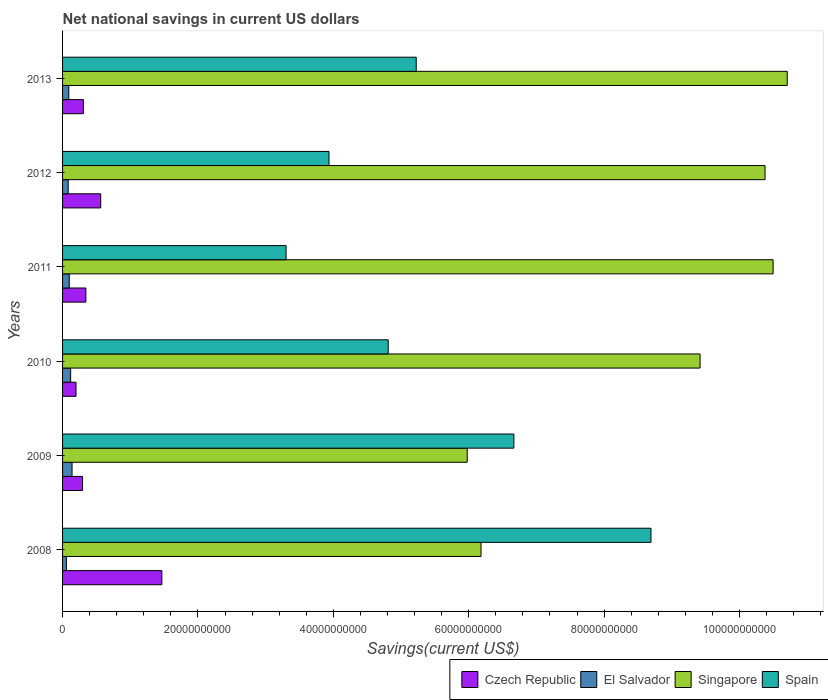How many different coloured bars are there?
Keep it short and to the point. 4. Are the number of bars on each tick of the Y-axis equal?
Keep it short and to the point. Yes. How many bars are there on the 6th tick from the top?
Provide a succinct answer. 4. In how many cases, is the number of bars for a given year not equal to the number of legend labels?
Make the answer very short. 0. What is the net national savings in Spain in 2010?
Your response must be concise. 4.81e+1. Across all years, what is the maximum net national savings in Czech Republic?
Offer a terse response. 1.47e+1. Across all years, what is the minimum net national savings in Spain?
Offer a very short reply. 3.30e+1. What is the total net national savings in Czech Republic in the graph?
Your answer should be compact. 3.18e+1. What is the difference between the net national savings in Czech Republic in 2010 and that in 2013?
Make the answer very short. -1.09e+09. What is the difference between the net national savings in Singapore in 2010 and the net national savings in El Salvador in 2008?
Make the answer very short. 9.36e+1. What is the average net national savings in Czech Republic per year?
Provide a succinct answer. 5.29e+09. In the year 2010, what is the difference between the net national savings in Spain and net national savings in El Salvador?
Your response must be concise. 4.69e+1. In how many years, is the net national savings in Singapore greater than 24000000000 US$?
Ensure brevity in your answer.  6. What is the ratio of the net national savings in Spain in 2012 to that in 2013?
Give a very brief answer. 0.75. Is the net national savings in El Salvador in 2010 less than that in 2013?
Give a very brief answer. No. What is the difference between the highest and the second highest net national savings in Czech Republic?
Your response must be concise. 9.03e+09. What is the difference between the highest and the lowest net national savings in Spain?
Provide a succinct answer. 5.39e+1. In how many years, is the net national savings in El Salvador greater than the average net national savings in El Salvador taken over all years?
Offer a terse response. 3. Is it the case that in every year, the sum of the net national savings in El Salvador and net national savings in Singapore is greater than the sum of net national savings in Spain and net national savings in Czech Republic?
Your answer should be compact. Yes. What does the 2nd bar from the top in 2010 represents?
Provide a succinct answer. Singapore. What does the 3rd bar from the bottom in 2013 represents?
Provide a succinct answer. Singapore. Is it the case that in every year, the sum of the net national savings in Spain and net national savings in El Salvador is greater than the net national savings in Singapore?
Keep it short and to the point. No. How many years are there in the graph?
Provide a short and direct response. 6. Does the graph contain any zero values?
Provide a succinct answer. No. Does the graph contain grids?
Make the answer very short. No. Where does the legend appear in the graph?
Your answer should be compact. Bottom right. How many legend labels are there?
Give a very brief answer. 4. What is the title of the graph?
Provide a succinct answer. Net national savings in current US dollars. Does "Egypt, Arab Rep." appear as one of the legend labels in the graph?
Give a very brief answer. No. What is the label or title of the X-axis?
Make the answer very short. Savings(current US$). What is the Savings(current US$) of Czech Republic in 2008?
Your response must be concise. 1.47e+1. What is the Savings(current US$) in El Salvador in 2008?
Offer a very short reply. 5.68e+08. What is the Savings(current US$) of Singapore in 2008?
Provide a short and direct response. 6.18e+1. What is the Savings(current US$) of Spain in 2008?
Your answer should be very brief. 8.69e+1. What is the Savings(current US$) of Czech Republic in 2009?
Your answer should be very brief. 2.95e+09. What is the Savings(current US$) in El Salvador in 2009?
Your answer should be compact. 1.40e+09. What is the Savings(current US$) of Singapore in 2009?
Give a very brief answer. 5.98e+1. What is the Savings(current US$) of Spain in 2009?
Keep it short and to the point. 6.67e+1. What is the Savings(current US$) of Czech Republic in 2010?
Ensure brevity in your answer.  1.99e+09. What is the Savings(current US$) in El Salvador in 2010?
Make the answer very short. 1.19e+09. What is the Savings(current US$) of Singapore in 2010?
Offer a terse response. 9.42e+1. What is the Savings(current US$) in Spain in 2010?
Give a very brief answer. 4.81e+1. What is the Savings(current US$) in Czech Republic in 2011?
Keep it short and to the point. 3.44e+09. What is the Savings(current US$) of El Salvador in 2011?
Your response must be concise. 9.87e+08. What is the Savings(current US$) of Singapore in 2011?
Your answer should be compact. 1.05e+11. What is the Savings(current US$) of Spain in 2011?
Keep it short and to the point. 3.30e+1. What is the Savings(current US$) of Czech Republic in 2012?
Offer a very short reply. 5.64e+09. What is the Savings(current US$) of El Salvador in 2012?
Make the answer very short. 8.30e+08. What is the Savings(current US$) in Singapore in 2012?
Your answer should be very brief. 1.04e+11. What is the Savings(current US$) in Spain in 2012?
Offer a very short reply. 3.94e+1. What is the Savings(current US$) in Czech Republic in 2013?
Keep it short and to the point. 3.07e+09. What is the Savings(current US$) of El Salvador in 2013?
Keep it short and to the point. 9.19e+08. What is the Savings(current US$) of Singapore in 2013?
Keep it short and to the point. 1.07e+11. What is the Savings(current US$) in Spain in 2013?
Ensure brevity in your answer.  5.22e+1. Across all years, what is the maximum Savings(current US$) of Czech Republic?
Your answer should be very brief. 1.47e+1. Across all years, what is the maximum Savings(current US$) in El Salvador?
Give a very brief answer. 1.40e+09. Across all years, what is the maximum Savings(current US$) of Singapore?
Your answer should be very brief. 1.07e+11. Across all years, what is the maximum Savings(current US$) of Spain?
Provide a short and direct response. 8.69e+1. Across all years, what is the minimum Savings(current US$) of Czech Republic?
Keep it short and to the point. 1.99e+09. Across all years, what is the minimum Savings(current US$) of El Salvador?
Keep it short and to the point. 5.68e+08. Across all years, what is the minimum Savings(current US$) of Singapore?
Your answer should be very brief. 5.98e+1. Across all years, what is the minimum Savings(current US$) in Spain?
Provide a short and direct response. 3.30e+1. What is the total Savings(current US$) of Czech Republic in the graph?
Make the answer very short. 3.18e+1. What is the total Savings(current US$) in El Salvador in the graph?
Keep it short and to the point. 5.90e+09. What is the total Savings(current US$) of Singapore in the graph?
Your answer should be compact. 5.32e+11. What is the total Savings(current US$) in Spain in the graph?
Ensure brevity in your answer.  3.26e+11. What is the difference between the Savings(current US$) in Czech Republic in 2008 and that in 2009?
Make the answer very short. 1.17e+1. What is the difference between the Savings(current US$) in El Salvador in 2008 and that in 2009?
Ensure brevity in your answer.  -8.33e+08. What is the difference between the Savings(current US$) in Singapore in 2008 and that in 2009?
Keep it short and to the point. 2.04e+09. What is the difference between the Savings(current US$) of Spain in 2008 and that in 2009?
Offer a very short reply. 2.03e+1. What is the difference between the Savings(current US$) in Czech Republic in 2008 and that in 2010?
Your response must be concise. 1.27e+1. What is the difference between the Savings(current US$) of El Salvador in 2008 and that in 2010?
Provide a succinct answer. -6.24e+08. What is the difference between the Savings(current US$) in Singapore in 2008 and that in 2010?
Provide a short and direct response. -3.24e+1. What is the difference between the Savings(current US$) in Spain in 2008 and that in 2010?
Your answer should be very brief. 3.88e+1. What is the difference between the Savings(current US$) in Czech Republic in 2008 and that in 2011?
Give a very brief answer. 1.12e+1. What is the difference between the Savings(current US$) of El Salvador in 2008 and that in 2011?
Give a very brief answer. -4.18e+08. What is the difference between the Savings(current US$) of Singapore in 2008 and that in 2011?
Your answer should be compact. -4.31e+1. What is the difference between the Savings(current US$) in Spain in 2008 and that in 2011?
Your answer should be very brief. 5.39e+1. What is the difference between the Savings(current US$) in Czech Republic in 2008 and that in 2012?
Offer a very short reply. 9.03e+09. What is the difference between the Savings(current US$) of El Salvador in 2008 and that in 2012?
Keep it short and to the point. -2.62e+08. What is the difference between the Savings(current US$) in Singapore in 2008 and that in 2012?
Provide a succinct answer. -4.20e+1. What is the difference between the Savings(current US$) of Spain in 2008 and that in 2012?
Provide a short and direct response. 4.76e+1. What is the difference between the Savings(current US$) in Czech Republic in 2008 and that in 2013?
Give a very brief answer. 1.16e+1. What is the difference between the Savings(current US$) of El Salvador in 2008 and that in 2013?
Your answer should be very brief. -3.51e+08. What is the difference between the Savings(current US$) of Singapore in 2008 and that in 2013?
Your answer should be compact. -4.52e+1. What is the difference between the Savings(current US$) in Spain in 2008 and that in 2013?
Provide a short and direct response. 3.47e+1. What is the difference between the Savings(current US$) of Czech Republic in 2009 and that in 2010?
Your answer should be compact. 9.65e+08. What is the difference between the Savings(current US$) in El Salvador in 2009 and that in 2010?
Give a very brief answer. 2.10e+08. What is the difference between the Savings(current US$) of Singapore in 2009 and that in 2010?
Provide a succinct answer. -3.44e+1. What is the difference between the Savings(current US$) of Spain in 2009 and that in 2010?
Make the answer very short. 1.86e+1. What is the difference between the Savings(current US$) in Czech Republic in 2009 and that in 2011?
Provide a short and direct response. -4.91e+08. What is the difference between the Savings(current US$) in El Salvador in 2009 and that in 2011?
Make the answer very short. 4.15e+08. What is the difference between the Savings(current US$) of Singapore in 2009 and that in 2011?
Offer a terse response. -4.52e+1. What is the difference between the Savings(current US$) of Spain in 2009 and that in 2011?
Offer a very short reply. 3.37e+1. What is the difference between the Savings(current US$) of Czech Republic in 2009 and that in 2012?
Ensure brevity in your answer.  -2.68e+09. What is the difference between the Savings(current US$) of El Salvador in 2009 and that in 2012?
Make the answer very short. 5.71e+08. What is the difference between the Savings(current US$) of Singapore in 2009 and that in 2012?
Keep it short and to the point. -4.40e+1. What is the difference between the Savings(current US$) of Spain in 2009 and that in 2012?
Your answer should be compact. 2.73e+1. What is the difference between the Savings(current US$) in Czech Republic in 2009 and that in 2013?
Keep it short and to the point. -1.21e+08. What is the difference between the Savings(current US$) in El Salvador in 2009 and that in 2013?
Offer a terse response. 4.82e+08. What is the difference between the Savings(current US$) of Singapore in 2009 and that in 2013?
Your answer should be compact. -4.73e+1. What is the difference between the Savings(current US$) of Spain in 2009 and that in 2013?
Give a very brief answer. 1.44e+1. What is the difference between the Savings(current US$) of Czech Republic in 2010 and that in 2011?
Your response must be concise. -1.46e+09. What is the difference between the Savings(current US$) of El Salvador in 2010 and that in 2011?
Offer a very short reply. 2.05e+08. What is the difference between the Savings(current US$) in Singapore in 2010 and that in 2011?
Provide a succinct answer. -1.08e+1. What is the difference between the Savings(current US$) in Spain in 2010 and that in 2011?
Provide a short and direct response. 1.51e+1. What is the difference between the Savings(current US$) in Czech Republic in 2010 and that in 2012?
Your response must be concise. -3.65e+09. What is the difference between the Savings(current US$) in El Salvador in 2010 and that in 2012?
Make the answer very short. 3.62e+08. What is the difference between the Savings(current US$) in Singapore in 2010 and that in 2012?
Your answer should be compact. -9.60e+09. What is the difference between the Savings(current US$) of Spain in 2010 and that in 2012?
Offer a terse response. 8.75e+09. What is the difference between the Savings(current US$) of Czech Republic in 2010 and that in 2013?
Your response must be concise. -1.09e+09. What is the difference between the Savings(current US$) in El Salvador in 2010 and that in 2013?
Your answer should be very brief. 2.73e+08. What is the difference between the Savings(current US$) in Singapore in 2010 and that in 2013?
Offer a terse response. -1.29e+1. What is the difference between the Savings(current US$) of Spain in 2010 and that in 2013?
Give a very brief answer. -4.14e+09. What is the difference between the Savings(current US$) of Czech Republic in 2011 and that in 2012?
Give a very brief answer. -2.19e+09. What is the difference between the Savings(current US$) in El Salvador in 2011 and that in 2012?
Make the answer very short. 1.56e+08. What is the difference between the Savings(current US$) in Singapore in 2011 and that in 2012?
Your response must be concise. 1.19e+09. What is the difference between the Savings(current US$) of Spain in 2011 and that in 2012?
Provide a short and direct response. -6.34e+09. What is the difference between the Savings(current US$) in Czech Republic in 2011 and that in 2013?
Keep it short and to the point. 3.71e+08. What is the difference between the Savings(current US$) of El Salvador in 2011 and that in 2013?
Make the answer very short. 6.75e+07. What is the difference between the Savings(current US$) in Singapore in 2011 and that in 2013?
Your answer should be compact. -2.09e+09. What is the difference between the Savings(current US$) of Spain in 2011 and that in 2013?
Ensure brevity in your answer.  -1.92e+1. What is the difference between the Savings(current US$) in Czech Republic in 2012 and that in 2013?
Your answer should be compact. 2.56e+09. What is the difference between the Savings(current US$) in El Salvador in 2012 and that in 2013?
Make the answer very short. -8.90e+07. What is the difference between the Savings(current US$) in Singapore in 2012 and that in 2013?
Make the answer very short. -3.28e+09. What is the difference between the Savings(current US$) of Spain in 2012 and that in 2013?
Provide a succinct answer. -1.29e+1. What is the difference between the Savings(current US$) in Czech Republic in 2008 and the Savings(current US$) in El Salvador in 2009?
Your answer should be compact. 1.33e+1. What is the difference between the Savings(current US$) of Czech Republic in 2008 and the Savings(current US$) of Singapore in 2009?
Offer a terse response. -4.51e+1. What is the difference between the Savings(current US$) in Czech Republic in 2008 and the Savings(current US$) in Spain in 2009?
Provide a succinct answer. -5.20e+1. What is the difference between the Savings(current US$) in El Salvador in 2008 and the Savings(current US$) in Singapore in 2009?
Your answer should be compact. -5.92e+1. What is the difference between the Savings(current US$) of El Salvador in 2008 and the Savings(current US$) of Spain in 2009?
Provide a succinct answer. -6.61e+1. What is the difference between the Savings(current US$) of Singapore in 2008 and the Savings(current US$) of Spain in 2009?
Your response must be concise. -4.85e+09. What is the difference between the Savings(current US$) of Czech Republic in 2008 and the Savings(current US$) of El Salvador in 2010?
Your response must be concise. 1.35e+1. What is the difference between the Savings(current US$) in Czech Republic in 2008 and the Savings(current US$) in Singapore in 2010?
Give a very brief answer. -7.95e+1. What is the difference between the Savings(current US$) of Czech Republic in 2008 and the Savings(current US$) of Spain in 2010?
Provide a short and direct response. -3.34e+1. What is the difference between the Savings(current US$) of El Salvador in 2008 and the Savings(current US$) of Singapore in 2010?
Offer a very short reply. -9.36e+1. What is the difference between the Savings(current US$) of El Salvador in 2008 and the Savings(current US$) of Spain in 2010?
Provide a succinct answer. -4.75e+1. What is the difference between the Savings(current US$) of Singapore in 2008 and the Savings(current US$) of Spain in 2010?
Ensure brevity in your answer.  1.37e+1. What is the difference between the Savings(current US$) in Czech Republic in 2008 and the Savings(current US$) in El Salvador in 2011?
Make the answer very short. 1.37e+1. What is the difference between the Savings(current US$) of Czech Republic in 2008 and the Savings(current US$) of Singapore in 2011?
Provide a succinct answer. -9.03e+1. What is the difference between the Savings(current US$) in Czech Republic in 2008 and the Savings(current US$) in Spain in 2011?
Provide a short and direct response. -1.84e+1. What is the difference between the Savings(current US$) of El Salvador in 2008 and the Savings(current US$) of Singapore in 2011?
Give a very brief answer. -1.04e+11. What is the difference between the Savings(current US$) in El Salvador in 2008 and the Savings(current US$) in Spain in 2011?
Keep it short and to the point. -3.24e+1. What is the difference between the Savings(current US$) of Singapore in 2008 and the Savings(current US$) of Spain in 2011?
Offer a very short reply. 2.88e+1. What is the difference between the Savings(current US$) of Czech Republic in 2008 and the Savings(current US$) of El Salvador in 2012?
Offer a very short reply. 1.38e+1. What is the difference between the Savings(current US$) of Czech Republic in 2008 and the Savings(current US$) of Singapore in 2012?
Provide a succinct answer. -8.91e+1. What is the difference between the Savings(current US$) of Czech Republic in 2008 and the Savings(current US$) of Spain in 2012?
Provide a short and direct response. -2.47e+1. What is the difference between the Savings(current US$) in El Salvador in 2008 and the Savings(current US$) in Singapore in 2012?
Provide a short and direct response. -1.03e+11. What is the difference between the Savings(current US$) in El Salvador in 2008 and the Savings(current US$) in Spain in 2012?
Offer a terse response. -3.88e+1. What is the difference between the Savings(current US$) in Singapore in 2008 and the Savings(current US$) in Spain in 2012?
Offer a terse response. 2.25e+1. What is the difference between the Savings(current US$) of Czech Republic in 2008 and the Savings(current US$) of El Salvador in 2013?
Ensure brevity in your answer.  1.37e+1. What is the difference between the Savings(current US$) of Czech Republic in 2008 and the Savings(current US$) of Singapore in 2013?
Your response must be concise. -9.24e+1. What is the difference between the Savings(current US$) of Czech Republic in 2008 and the Savings(current US$) of Spain in 2013?
Give a very brief answer. -3.76e+1. What is the difference between the Savings(current US$) in El Salvador in 2008 and the Savings(current US$) in Singapore in 2013?
Provide a succinct answer. -1.06e+11. What is the difference between the Savings(current US$) of El Salvador in 2008 and the Savings(current US$) of Spain in 2013?
Give a very brief answer. -5.17e+1. What is the difference between the Savings(current US$) of Singapore in 2008 and the Savings(current US$) of Spain in 2013?
Keep it short and to the point. 9.57e+09. What is the difference between the Savings(current US$) in Czech Republic in 2009 and the Savings(current US$) in El Salvador in 2010?
Your response must be concise. 1.76e+09. What is the difference between the Savings(current US$) in Czech Republic in 2009 and the Savings(current US$) in Singapore in 2010?
Your answer should be compact. -9.12e+1. What is the difference between the Savings(current US$) in Czech Republic in 2009 and the Savings(current US$) in Spain in 2010?
Give a very brief answer. -4.52e+1. What is the difference between the Savings(current US$) in El Salvador in 2009 and the Savings(current US$) in Singapore in 2010?
Make the answer very short. -9.28e+1. What is the difference between the Savings(current US$) of El Salvador in 2009 and the Savings(current US$) of Spain in 2010?
Offer a very short reply. -4.67e+1. What is the difference between the Savings(current US$) of Singapore in 2009 and the Savings(current US$) of Spain in 2010?
Your answer should be compact. 1.17e+1. What is the difference between the Savings(current US$) in Czech Republic in 2009 and the Savings(current US$) in El Salvador in 2011?
Provide a short and direct response. 1.97e+09. What is the difference between the Savings(current US$) in Czech Republic in 2009 and the Savings(current US$) in Singapore in 2011?
Offer a very short reply. -1.02e+11. What is the difference between the Savings(current US$) in Czech Republic in 2009 and the Savings(current US$) in Spain in 2011?
Provide a succinct answer. -3.01e+1. What is the difference between the Savings(current US$) in El Salvador in 2009 and the Savings(current US$) in Singapore in 2011?
Offer a terse response. -1.04e+11. What is the difference between the Savings(current US$) in El Salvador in 2009 and the Savings(current US$) in Spain in 2011?
Your answer should be compact. -3.16e+1. What is the difference between the Savings(current US$) of Singapore in 2009 and the Savings(current US$) of Spain in 2011?
Your answer should be very brief. 2.68e+1. What is the difference between the Savings(current US$) of Czech Republic in 2009 and the Savings(current US$) of El Salvador in 2012?
Offer a very short reply. 2.12e+09. What is the difference between the Savings(current US$) in Czech Republic in 2009 and the Savings(current US$) in Singapore in 2012?
Your answer should be compact. -1.01e+11. What is the difference between the Savings(current US$) in Czech Republic in 2009 and the Savings(current US$) in Spain in 2012?
Give a very brief answer. -3.64e+1. What is the difference between the Savings(current US$) of El Salvador in 2009 and the Savings(current US$) of Singapore in 2012?
Offer a very short reply. -1.02e+11. What is the difference between the Savings(current US$) of El Salvador in 2009 and the Savings(current US$) of Spain in 2012?
Keep it short and to the point. -3.80e+1. What is the difference between the Savings(current US$) of Singapore in 2009 and the Savings(current US$) of Spain in 2012?
Offer a terse response. 2.04e+1. What is the difference between the Savings(current US$) in Czech Republic in 2009 and the Savings(current US$) in El Salvador in 2013?
Provide a short and direct response. 2.03e+09. What is the difference between the Savings(current US$) of Czech Republic in 2009 and the Savings(current US$) of Singapore in 2013?
Provide a short and direct response. -1.04e+11. What is the difference between the Savings(current US$) of Czech Republic in 2009 and the Savings(current US$) of Spain in 2013?
Offer a terse response. -4.93e+1. What is the difference between the Savings(current US$) in El Salvador in 2009 and the Savings(current US$) in Singapore in 2013?
Ensure brevity in your answer.  -1.06e+11. What is the difference between the Savings(current US$) of El Salvador in 2009 and the Savings(current US$) of Spain in 2013?
Keep it short and to the point. -5.08e+1. What is the difference between the Savings(current US$) of Singapore in 2009 and the Savings(current US$) of Spain in 2013?
Give a very brief answer. 7.53e+09. What is the difference between the Savings(current US$) of Czech Republic in 2010 and the Savings(current US$) of El Salvador in 2011?
Offer a terse response. 1.00e+09. What is the difference between the Savings(current US$) in Czech Republic in 2010 and the Savings(current US$) in Singapore in 2011?
Provide a short and direct response. -1.03e+11. What is the difference between the Savings(current US$) in Czech Republic in 2010 and the Savings(current US$) in Spain in 2011?
Offer a very short reply. -3.10e+1. What is the difference between the Savings(current US$) in El Salvador in 2010 and the Savings(current US$) in Singapore in 2011?
Your answer should be very brief. -1.04e+11. What is the difference between the Savings(current US$) of El Salvador in 2010 and the Savings(current US$) of Spain in 2011?
Provide a short and direct response. -3.18e+1. What is the difference between the Savings(current US$) of Singapore in 2010 and the Savings(current US$) of Spain in 2011?
Provide a succinct answer. 6.12e+1. What is the difference between the Savings(current US$) in Czech Republic in 2010 and the Savings(current US$) in El Salvador in 2012?
Your response must be concise. 1.16e+09. What is the difference between the Savings(current US$) of Czech Republic in 2010 and the Savings(current US$) of Singapore in 2012?
Keep it short and to the point. -1.02e+11. What is the difference between the Savings(current US$) of Czech Republic in 2010 and the Savings(current US$) of Spain in 2012?
Keep it short and to the point. -3.74e+1. What is the difference between the Savings(current US$) of El Salvador in 2010 and the Savings(current US$) of Singapore in 2012?
Your answer should be very brief. -1.03e+11. What is the difference between the Savings(current US$) in El Salvador in 2010 and the Savings(current US$) in Spain in 2012?
Offer a very short reply. -3.82e+1. What is the difference between the Savings(current US$) of Singapore in 2010 and the Savings(current US$) of Spain in 2012?
Offer a terse response. 5.48e+1. What is the difference between the Savings(current US$) in Czech Republic in 2010 and the Savings(current US$) in El Salvador in 2013?
Offer a terse response. 1.07e+09. What is the difference between the Savings(current US$) of Czech Republic in 2010 and the Savings(current US$) of Singapore in 2013?
Provide a succinct answer. -1.05e+11. What is the difference between the Savings(current US$) in Czech Republic in 2010 and the Savings(current US$) in Spain in 2013?
Ensure brevity in your answer.  -5.03e+1. What is the difference between the Savings(current US$) of El Salvador in 2010 and the Savings(current US$) of Singapore in 2013?
Keep it short and to the point. -1.06e+11. What is the difference between the Savings(current US$) in El Salvador in 2010 and the Savings(current US$) in Spain in 2013?
Make the answer very short. -5.11e+1. What is the difference between the Savings(current US$) in Singapore in 2010 and the Savings(current US$) in Spain in 2013?
Make the answer very short. 4.19e+1. What is the difference between the Savings(current US$) in Czech Republic in 2011 and the Savings(current US$) in El Salvador in 2012?
Offer a very short reply. 2.61e+09. What is the difference between the Savings(current US$) in Czech Republic in 2011 and the Savings(current US$) in Singapore in 2012?
Provide a succinct answer. -1.00e+11. What is the difference between the Savings(current US$) in Czech Republic in 2011 and the Savings(current US$) in Spain in 2012?
Provide a succinct answer. -3.59e+1. What is the difference between the Savings(current US$) in El Salvador in 2011 and the Savings(current US$) in Singapore in 2012?
Provide a succinct answer. -1.03e+11. What is the difference between the Savings(current US$) in El Salvador in 2011 and the Savings(current US$) in Spain in 2012?
Provide a succinct answer. -3.84e+1. What is the difference between the Savings(current US$) in Singapore in 2011 and the Savings(current US$) in Spain in 2012?
Give a very brief answer. 6.56e+1. What is the difference between the Savings(current US$) of Czech Republic in 2011 and the Savings(current US$) of El Salvador in 2013?
Your answer should be very brief. 2.52e+09. What is the difference between the Savings(current US$) in Czech Republic in 2011 and the Savings(current US$) in Singapore in 2013?
Provide a succinct answer. -1.04e+11. What is the difference between the Savings(current US$) of Czech Republic in 2011 and the Savings(current US$) of Spain in 2013?
Your answer should be very brief. -4.88e+1. What is the difference between the Savings(current US$) in El Salvador in 2011 and the Savings(current US$) in Singapore in 2013?
Give a very brief answer. -1.06e+11. What is the difference between the Savings(current US$) of El Salvador in 2011 and the Savings(current US$) of Spain in 2013?
Make the answer very short. -5.13e+1. What is the difference between the Savings(current US$) of Singapore in 2011 and the Savings(current US$) of Spain in 2013?
Your answer should be compact. 5.27e+1. What is the difference between the Savings(current US$) of Czech Republic in 2012 and the Savings(current US$) of El Salvador in 2013?
Provide a short and direct response. 4.72e+09. What is the difference between the Savings(current US$) of Czech Republic in 2012 and the Savings(current US$) of Singapore in 2013?
Offer a very short reply. -1.01e+11. What is the difference between the Savings(current US$) of Czech Republic in 2012 and the Savings(current US$) of Spain in 2013?
Give a very brief answer. -4.66e+1. What is the difference between the Savings(current US$) of El Salvador in 2012 and the Savings(current US$) of Singapore in 2013?
Your answer should be very brief. -1.06e+11. What is the difference between the Savings(current US$) in El Salvador in 2012 and the Savings(current US$) in Spain in 2013?
Your response must be concise. -5.14e+1. What is the difference between the Savings(current US$) of Singapore in 2012 and the Savings(current US$) of Spain in 2013?
Your answer should be compact. 5.15e+1. What is the average Savings(current US$) of Czech Republic per year?
Provide a short and direct response. 5.29e+09. What is the average Savings(current US$) of El Salvador per year?
Offer a terse response. 9.83e+08. What is the average Savings(current US$) in Singapore per year?
Make the answer very short. 8.86e+1. What is the average Savings(current US$) of Spain per year?
Provide a short and direct response. 5.44e+1. In the year 2008, what is the difference between the Savings(current US$) in Czech Republic and Savings(current US$) in El Salvador?
Your answer should be very brief. 1.41e+1. In the year 2008, what is the difference between the Savings(current US$) in Czech Republic and Savings(current US$) in Singapore?
Offer a very short reply. -4.72e+1. In the year 2008, what is the difference between the Savings(current US$) of Czech Republic and Savings(current US$) of Spain?
Provide a succinct answer. -7.23e+1. In the year 2008, what is the difference between the Savings(current US$) in El Salvador and Savings(current US$) in Singapore?
Make the answer very short. -6.12e+1. In the year 2008, what is the difference between the Savings(current US$) in El Salvador and Savings(current US$) in Spain?
Offer a terse response. -8.64e+1. In the year 2008, what is the difference between the Savings(current US$) of Singapore and Savings(current US$) of Spain?
Give a very brief answer. -2.51e+1. In the year 2009, what is the difference between the Savings(current US$) of Czech Republic and Savings(current US$) of El Salvador?
Provide a succinct answer. 1.55e+09. In the year 2009, what is the difference between the Savings(current US$) of Czech Republic and Savings(current US$) of Singapore?
Offer a very short reply. -5.68e+1. In the year 2009, what is the difference between the Savings(current US$) of Czech Republic and Savings(current US$) of Spain?
Keep it short and to the point. -6.37e+1. In the year 2009, what is the difference between the Savings(current US$) of El Salvador and Savings(current US$) of Singapore?
Ensure brevity in your answer.  -5.84e+1. In the year 2009, what is the difference between the Savings(current US$) of El Salvador and Savings(current US$) of Spain?
Offer a terse response. -6.53e+1. In the year 2009, what is the difference between the Savings(current US$) of Singapore and Savings(current US$) of Spain?
Keep it short and to the point. -6.89e+09. In the year 2010, what is the difference between the Savings(current US$) of Czech Republic and Savings(current US$) of El Salvador?
Offer a terse response. 7.96e+08. In the year 2010, what is the difference between the Savings(current US$) of Czech Republic and Savings(current US$) of Singapore?
Your answer should be compact. -9.22e+1. In the year 2010, what is the difference between the Savings(current US$) in Czech Republic and Savings(current US$) in Spain?
Provide a succinct answer. -4.61e+1. In the year 2010, what is the difference between the Savings(current US$) in El Salvador and Savings(current US$) in Singapore?
Ensure brevity in your answer.  -9.30e+1. In the year 2010, what is the difference between the Savings(current US$) in El Salvador and Savings(current US$) in Spain?
Your answer should be compact. -4.69e+1. In the year 2010, what is the difference between the Savings(current US$) in Singapore and Savings(current US$) in Spain?
Keep it short and to the point. 4.61e+1. In the year 2011, what is the difference between the Savings(current US$) in Czech Republic and Savings(current US$) in El Salvador?
Provide a short and direct response. 2.46e+09. In the year 2011, what is the difference between the Savings(current US$) in Czech Republic and Savings(current US$) in Singapore?
Ensure brevity in your answer.  -1.02e+11. In the year 2011, what is the difference between the Savings(current US$) in Czech Republic and Savings(current US$) in Spain?
Keep it short and to the point. -2.96e+1. In the year 2011, what is the difference between the Savings(current US$) in El Salvador and Savings(current US$) in Singapore?
Ensure brevity in your answer.  -1.04e+11. In the year 2011, what is the difference between the Savings(current US$) of El Salvador and Savings(current US$) of Spain?
Provide a succinct answer. -3.20e+1. In the year 2011, what is the difference between the Savings(current US$) of Singapore and Savings(current US$) of Spain?
Give a very brief answer. 7.19e+1. In the year 2012, what is the difference between the Savings(current US$) in Czech Republic and Savings(current US$) in El Salvador?
Offer a very short reply. 4.81e+09. In the year 2012, what is the difference between the Savings(current US$) in Czech Republic and Savings(current US$) in Singapore?
Offer a very short reply. -9.81e+1. In the year 2012, what is the difference between the Savings(current US$) of Czech Republic and Savings(current US$) of Spain?
Your response must be concise. -3.37e+1. In the year 2012, what is the difference between the Savings(current US$) in El Salvador and Savings(current US$) in Singapore?
Your answer should be very brief. -1.03e+11. In the year 2012, what is the difference between the Savings(current US$) of El Salvador and Savings(current US$) of Spain?
Keep it short and to the point. -3.85e+1. In the year 2012, what is the difference between the Savings(current US$) of Singapore and Savings(current US$) of Spain?
Make the answer very short. 6.44e+1. In the year 2013, what is the difference between the Savings(current US$) of Czech Republic and Savings(current US$) of El Salvador?
Your response must be concise. 2.15e+09. In the year 2013, what is the difference between the Savings(current US$) in Czech Republic and Savings(current US$) in Singapore?
Give a very brief answer. -1.04e+11. In the year 2013, what is the difference between the Savings(current US$) of Czech Republic and Savings(current US$) of Spain?
Keep it short and to the point. -4.92e+1. In the year 2013, what is the difference between the Savings(current US$) in El Salvador and Savings(current US$) in Singapore?
Ensure brevity in your answer.  -1.06e+11. In the year 2013, what is the difference between the Savings(current US$) of El Salvador and Savings(current US$) of Spain?
Give a very brief answer. -5.13e+1. In the year 2013, what is the difference between the Savings(current US$) of Singapore and Savings(current US$) of Spain?
Provide a succinct answer. 5.48e+1. What is the ratio of the Savings(current US$) in Czech Republic in 2008 to that in 2009?
Offer a terse response. 4.97. What is the ratio of the Savings(current US$) in El Salvador in 2008 to that in 2009?
Ensure brevity in your answer.  0.41. What is the ratio of the Savings(current US$) of Singapore in 2008 to that in 2009?
Offer a terse response. 1.03. What is the ratio of the Savings(current US$) of Spain in 2008 to that in 2009?
Offer a terse response. 1.3. What is the ratio of the Savings(current US$) in Czech Republic in 2008 to that in 2010?
Your response must be concise. 7.38. What is the ratio of the Savings(current US$) in El Salvador in 2008 to that in 2010?
Your answer should be very brief. 0.48. What is the ratio of the Savings(current US$) of Singapore in 2008 to that in 2010?
Your answer should be compact. 0.66. What is the ratio of the Savings(current US$) in Spain in 2008 to that in 2010?
Offer a very short reply. 1.81. What is the ratio of the Savings(current US$) in Czech Republic in 2008 to that in 2011?
Ensure brevity in your answer.  4.26. What is the ratio of the Savings(current US$) in El Salvador in 2008 to that in 2011?
Provide a succinct answer. 0.58. What is the ratio of the Savings(current US$) in Singapore in 2008 to that in 2011?
Offer a very short reply. 0.59. What is the ratio of the Savings(current US$) of Spain in 2008 to that in 2011?
Offer a very short reply. 2.63. What is the ratio of the Savings(current US$) of Czech Republic in 2008 to that in 2012?
Your answer should be compact. 2.6. What is the ratio of the Savings(current US$) in El Salvador in 2008 to that in 2012?
Ensure brevity in your answer.  0.68. What is the ratio of the Savings(current US$) of Singapore in 2008 to that in 2012?
Offer a very short reply. 0.6. What is the ratio of the Savings(current US$) in Spain in 2008 to that in 2012?
Your answer should be compact. 2.21. What is the ratio of the Savings(current US$) in Czech Republic in 2008 to that in 2013?
Offer a very short reply. 4.77. What is the ratio of the Savings(current US$) of El Salvador in 2008 to that in 2013?
Provide a succinct answer. 0.62. What is the ratio of the Savings(current US$) of Singapore in 2008 to that in 2013?
Your response must be concise. 0.58. What is the ratio of the Savings(current US$) in Spain in 2008 to that in 2013?
Your response must be concise. 1.66. What is the ratio of the Savings(current US$) of Czech Republic in 2009 to that in 2010?
Make the answer very short. 1.49. What is the ratio of the Savings(current US$) of El Salvador in 2009 to that in 2010?
Give a very brief answer. 1.18. What is the ratio of the Savings(current US$) of Singapore in 2009 to that in 2010?
Make the answer very short. 0.63. What is the ratio of the Savings(current US$) of Spain in 2009 to that in 2010?
Your response must be concise. 1.39. What is the ratio of the Savings(current US$) of Czech Republic in 2009 to that in 2011?
Keep it short and to the point. 0.86. What is the ratio of the Savings(current US$) in El Salvador in 2009 to that in 2011?
Provide a succinct answer. 1.42. What is the ratio of the Savings(current US$) of Singapore in 2009 to that in 2011?
Give a very brief answer. 0.57. What is the ratio of the Savings(current US$) in Spain in 2009 to that in 2011?
Offer a terse response. 2.02. What is the ratio of the Savings(current US$) of Czech Republic in 2009 to that in 2012?
Offer a terse response. 0.52. What is the ratio of the Savings(current US$) in El Salvador in 2009 to that in 2012?
Your answer should be very brief. 1.69. What is the ratio of the Savings(current US$) in Singapore in 2009 to that in 2012?
Your response must be concise. 0.58. What is the ratio of the Savings(current US$) of Spain in 2009 to that in 2012?
Ensure brevity in your answer.  1.69. What is the ratio of the Savings(current US$) in Czech Republic in 2009 to that in 2013?
Offer a terse response. 0.96. What is the ratio of the Savings(current US$) of El Salvador in 2009 to that in 2013?
Provide a succinct answer. 1.52. What is the ratio of the Savings(current US$) in Singapore in 2009 to that in 2013?
Offer a very short reply. 0.56. What is the ratio of the Savings(current US$) of Spain in 2009 to that in 2013?
Provide a succinct answer. 1.28. What is the ratio of the Savings(current US$) in Czech Republic in 2010 to that in 2011?
Offer a terse response. 0.58. What is the ratio of the Savings(current US$) in El Salvador in 2010 to that in 2011?
Give a very brief answer. 1.21. What is the ratio of the Savings(current US$) in Singapore in 2010 to that in 2011?
Your response must be concise. 0.9. What is the ratio of the Savings(current US$) in Spain in 2010 to that in 2011?
Ensure brevity in your answer.  1.46. What is the ratio of the Savings(current US$) in Czech Republic in 2010 to that in 2012?
Keep it short and to the point. 0.35. What is the ratio of the Savings(current US$) in El Salvador in 2010 to that in 2012?
Your answer should be very brief. 1.44. What is the ratio of the Savings(current US$) in Singapore in 2010 to that in 2012?
Keep it short and to the point. 0.91. What is the ratio of the Savings(current US$) in Spain in 2010 to that in 2012?
Offer a terse response. 1.22. What is the ratio of the Savings(current US$) of Czech Republic in 2010 to that in 2013?
Provide a succinct answer. 0.65. What is the ratio of the Savings(current US$) of El Salvador in 2010 to that in 2013?
Give a very brief answer. 1.3. What is the ratio of the Savings(current US$) in Singapore in 2010 to that in 2013?
Provide a succinct answer. 0.88. What is the ratio of the Savings(current US$) of Spain in 2010 to that in 2013?
Your response must be concise. 0.92. What is the ratio of the Savings(current US$) in Czech Republic in 2011 to that in 2012?
Provide a short and direct response. 0.61. What is the ratio of the Savings(current US$) of El Salvador in 2011 to that in 2012?
Keep it short and to the point. 1.19. What is the ratio of the Savings(current US$) in Singapore in 2011 to that in 2012?
Offer a very short reply. 1.01. What is the ratio of the Savings(current US$) of Spain in 2011 to that in 2012?
Offer a very short reply. 0.84. What is the ratio of the Savings(current US$) in Czech Republic in 2011 to that in 2013?
Make the answer very short. 1.12. What is the ratio of the Savings(current US$) of El Salvador in 2011 to that in 2013?
Give a very brief answer. 1.07. What is the ratio of the Savings(current US$) of Singapore in 2011 to that in 2013?
Provide a short and direct response. 0.98. What is the ratio of the Savings(current US$) of Spain in 2011 to that in 2013?
Your response must be concise. 0.63. What is the ratio of the Savings(current US$) in Czech Republic in 2012 to that in 2013?
Your response must be concise. 1.83. What is the ratio of the Savings(current US$) of El Salvador in 2012 to that in 2013?
Your answer should be very brief. 0.9. What is the ratio of the Savings(current US$) of Singapore in 2012 to that in 2013?
Offer a terse response. 0.97. What is the ratio of the Savings(current US$) of Spain in 2012 to that in 2013?
Offer a very short reply. 0.75. What is the difference between the highest and the second highest Savings(current US$) of Czech Republic?
Keep it short and to the point. 9.03e+09. What is the difference between the highest and the second highest Savings(current US$) in El Salvador?
Offer a terse response. 2.10e+08. What is the difference between the highest and the second highest Savings(current US$) in Singapore?
Keep it short and to the point. 2.09e+09. What is the difference between the highest and the second highest Savings(current US$) of Spain?
Offer a terse response. 2.03e+1. What is the difference between the highest and the lowest Savings(current US$) of Czech Republic?
Ensure brevity in your answer.  1.27e+1. What is the difference between the highest and the lowest Savings(current US$) of El Salvador?
Ensure brevity in your answer.  8.33e+08. What is the difference between the highest and the lowest Savings(current US$) in Singapore?
Offer a terse response. 4.73e+1. What is the difference between the highest and the lowest Savings(current US$) in Spain?
Provide a short and direct response. 5.39e+1. 